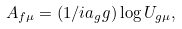Convert formula to latex. <formula><loc_0><loc_0><loc_500><loc_500>A _ { f \mu } = ( 1 / i a _ { g } g ) \log U _ { g \mu } ,</formula> 